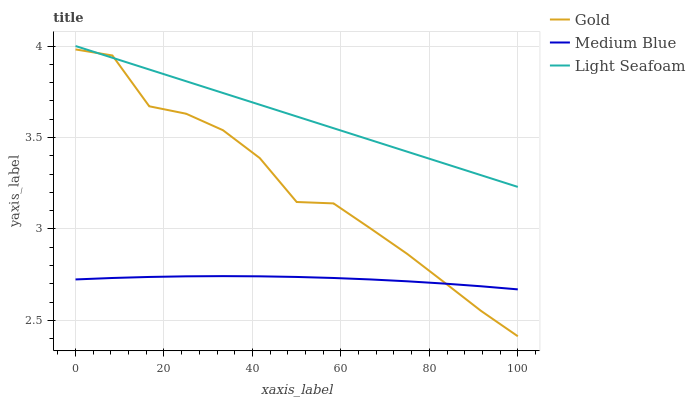Does Medium Blue have the minimum area under the curve?
Answer yes or no. Yes. Does Light Seafoam have the maximum area under the curve?
Answer yes or no. Yes. Does Gold have the minimum area under the curve?
Answer yes or no. No. Does Gold have the maximum area under the curve?
Answer yes or no. No. Is Light Seafoam the smoothest?
Answer yes or no. Yes. Is Gold the roughest?
Answer yes or no. Yes. Is Medium Blue the smoothest?
Answer yes or no. No. Is Medium Blue the roughest?
Answer yes or no. No. Does Gold have the lowest value?
Answer yes or no. Yes. Does Medium Blue have the lowest value?
Answer yes or no. No. Does Light Seafoam have the highest value?
Answer yes or no. Yes. Does Gold have the highest value?
Answer yes or no. No. Is Medium Blue less than Light Seafoam?
Answer yes or no. Yes. Is Light Seafoam greater than Medium Blue?
Answer yes or no. Yes. Does Gold intersect Medium Blue?
Answer yes or no. Yes. Is Gold less than Medium Blue?
Answer yes or no. No. Is Gold greater than Medium Blue?
Answer yes or no. No. Does Medium Blue intersect Light Seafoam?
Answer yes or no. No. 